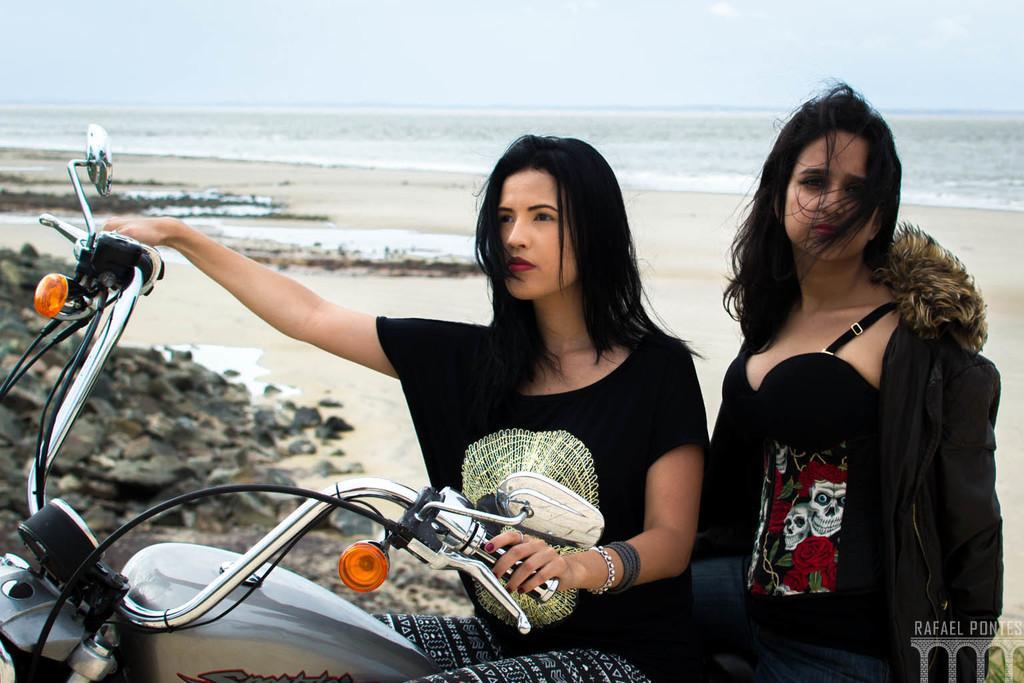Can you describe this image briefly? This woman's are sitting on a motorbike. This woman wore black jacket and t-shirt. This woman wore black t-shirt. This is a freshwater river. These are stones. 